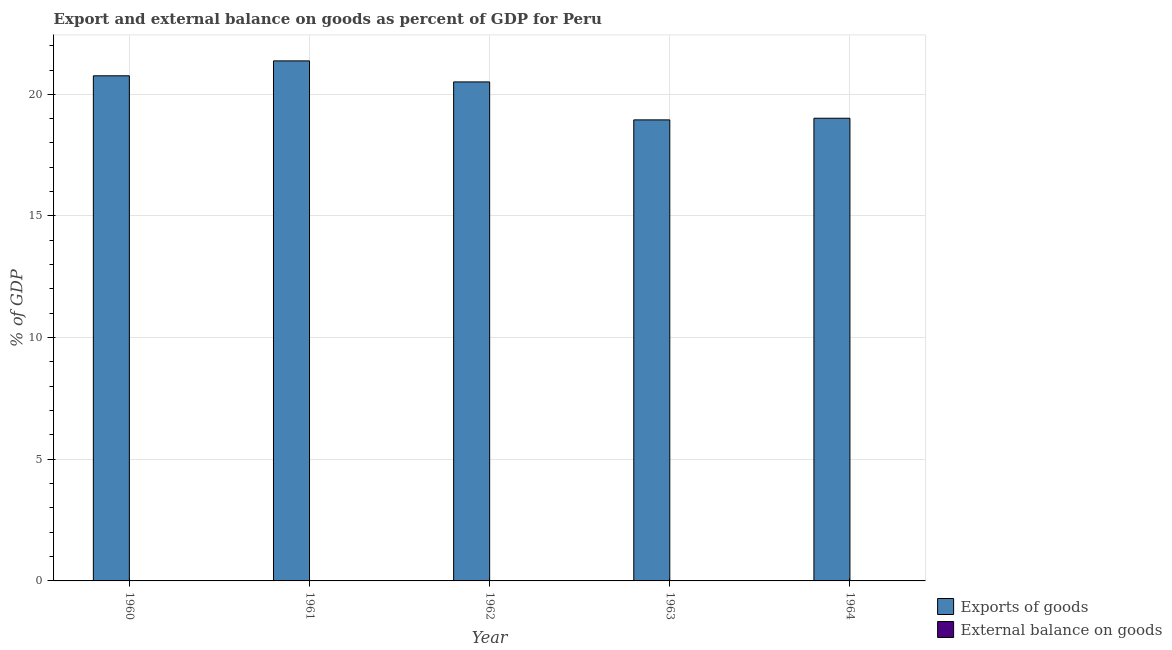How many different coloured bars are there?
Provide a succinct answer. 1. Are the number of bars per tick equal to the number of legend labels?
Your answer should be very brief. No. What is the external balance on goods as percentage of gdp in 1964?
Your answer should be very brief. 0. Across all years, what is the maximum export of goods as percentage of gdp?
Give a very brief answer. 21.38. Across all years, what is the minimum export of goods as percentage of gdp?
Offer a very short reply. 18.95. What is the total export of goods as percentage of gdp in the graph?
Give a very brief answer. 100.62. What is the difference between the export of goods as percentage of gdp in 1961 and that in 1962?
Offer a very short reply. 0.86. What is the difference between the export of goods as percentage of gdp in 1963 and the external balance on goods as percentage of gdp in 1960?
Make the answer very short. -1.81. What is the average export of goods as percentage of gdp per year?
Provide a succinct answer. 20.12. What is the ratio of the export of goods as percentage of gdp in 1962 to that in 1964?
Your answer should be very brief. 1.08. What is the difference between the highest and the second highest export of goods as percentage of gdp?
Provide a succinct answer. 0.61. What is the difference between the highest and the lowest export of goods as percentage of gdp?
Your answer should be compact. 2.43. Is the sum of the export of goods as percentage of gdp in 1960 and 1963 greater than the maximum external balance on goods as percentage of gdp across all years?
Offer a very short reply. Yes. Does the graph contain any zero values?
Offer a very short reply. Yes. Where does the legend appear in the graph?
Make the answer very short. Bottom right. What is the title of the graph?
Your response must be concise. Export and external balance on goods as percent of GDP for Peru. Does "GDP per capita" appear as one of the legend labels in the graph?
Your answer should be very brief. No. What is the label or title of the Y-axis?
Your response must be concise. % of GDP. What is the % of GDP of Exports of goods in 1960?
Make the answer very short. 20.76. What is the % of GDP in Exports of goods in 1961?
Your answer should be very brief. 21.38. What is the % of GDP in Exports of goods in 1962?
Keep it short and to the point. 20.51. What is the % of GDP of Exports of goods in 1963?
Provide a short and direct response. 18.95. What is the % of GDP of Exports of goods in 1964?
Your answer should be compact. 19.02. Across all years, what is the maximum % of GDP in Exports of goods?
Provide a short and direct response. 21.38. Across all years, what is the minimum % of GDP in Exports of goods?
Keep it short and to the point. 18.95. What is the total % of GDP of Exports of goods in the graph?
Your answer should be compact. 100.62. What is the difference between the % of GDP in Exports of goods in 1960 and that in 1961?
Provide a succinct answer. -0.61. What is the difference between the % of GDP of Exports of goods in 1960 and that in 1962?
Offer a terse response. 0.25. What is the difference between the % of GDP in Exports of goods in 1960 and that in 1963?
Your response must be concise. 1.81. What is the difference between the % of GDP in Exports of goods in 1960 and that in 1964?
Offer a terse response. 1.74. What is the difference between the % of GDP in Exports of goods in 1961 and that in 1962?
Keep it short and to the point. 0.86. What is the difference between the % of GDP of Exports of goods in 1961 and that in 1963?
Make the answer very short. 2.43. What is the difference between the % of GDP of Exports of goods in 1961 and that in 1964?
Make the answer very short. 2.36. What is the difference between the % of GDP in Exports of goods in 1962 and that in 1963?
Offer a very short reply. 1.56. What is the difference between the % of GDP of Exports of goods in 1962 and that in 1964?
Provide a short and direct response. 1.49. What is the difference between the % of GDP in Exports of goods in 1963 and that in 1964?
Your answer should be very brief. -0.07. What is the average % of GDP in Exports of goods per year?
Offer a very short reply. 20.12. What is the average % of GDP of External balance on goods per year?
Your response must be concise. 0. What is the ratio of the % of GDP of Exports of goods in 1960 to that in 1961?
Offer a terse response. 0.97. What is the ratio of the % of GDP in Exports of goods in 1960 to that in 1962?
Offer a very short reply. 1.01. What is the ratio of the % of GDP of Exports of goods in 1960 to that in 1963?
Give a very brief answer. 1.1. What is the ratio of the % of GDP of Exports of goods in 1960 to that in 1964?
Keep it short and to the point. 1.09. What is the ratio of the % of GDP in Exports of goods in 1961 to that in 1962?
Ensure brevity in your answer.  1.04. What is the ratio of the % of GDP of Exports of goods in 1961 to that in 1963?
Offer a very short reply. 1.13. What is the ratio of the % of GDP of Exports of goods in 1961 to that in 1964?
Give a very brief answer. 1.12. What is the ratio of the % of GDP in Exports of goods in 1962 to that in 1963?
Your answer should be compact. 1.08. What is the ratio of the % of GDP in Exports of goods in 1962 to that in 1964?
Your answer should be very brief. 1.08. What is the difference between the highest and the second highest % of GDP in Exports of goods?
Make the answer very short. 0.61. What is the difference between the highest and the lowest % of GDP in Exports of goods?
Your answer should be compact. 2.43. 